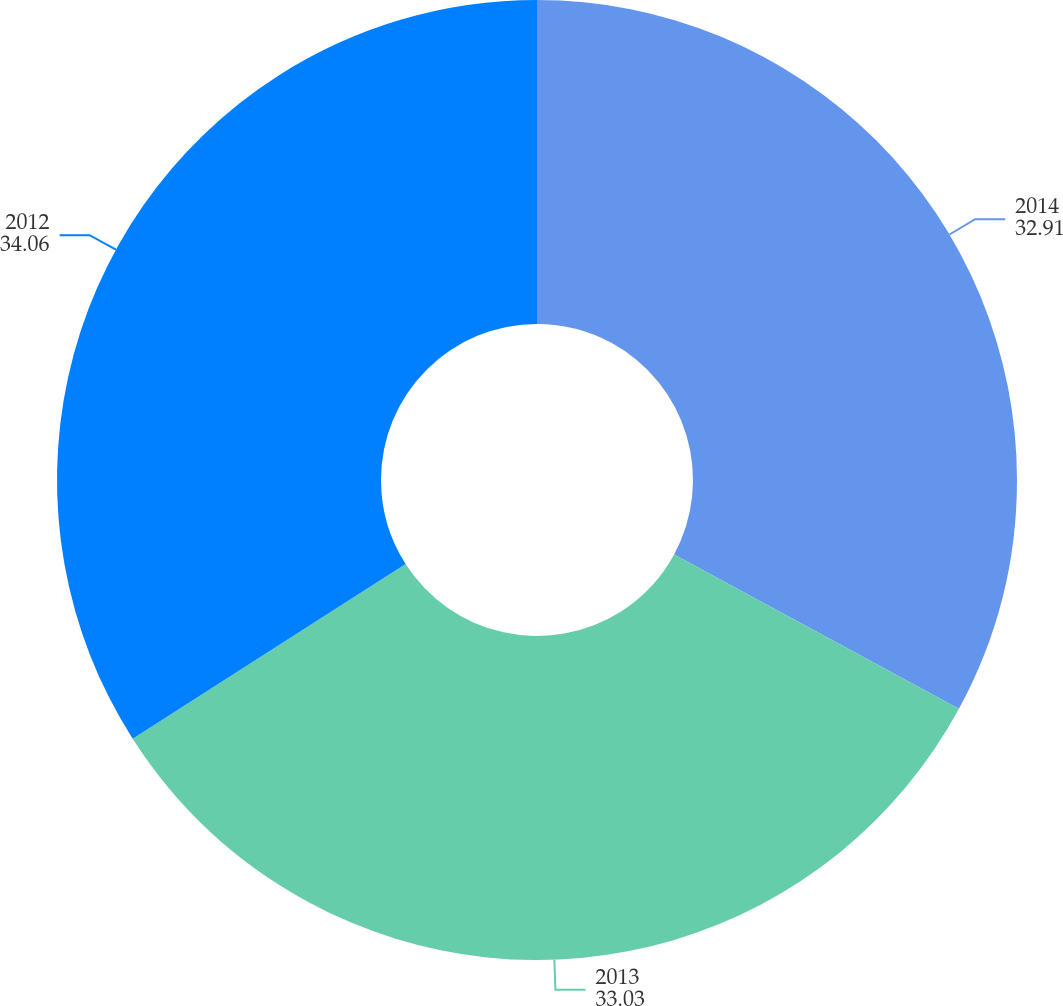Convert chart to OTSL. <chart><loc_0><loc_0><loc_500><loc_500><pie_chart><fcel>2014<fcel>2013<fcel>2012<nl><fcel>32.91%<fcel>33.03%<fcel>34.06%<nl></chart> 